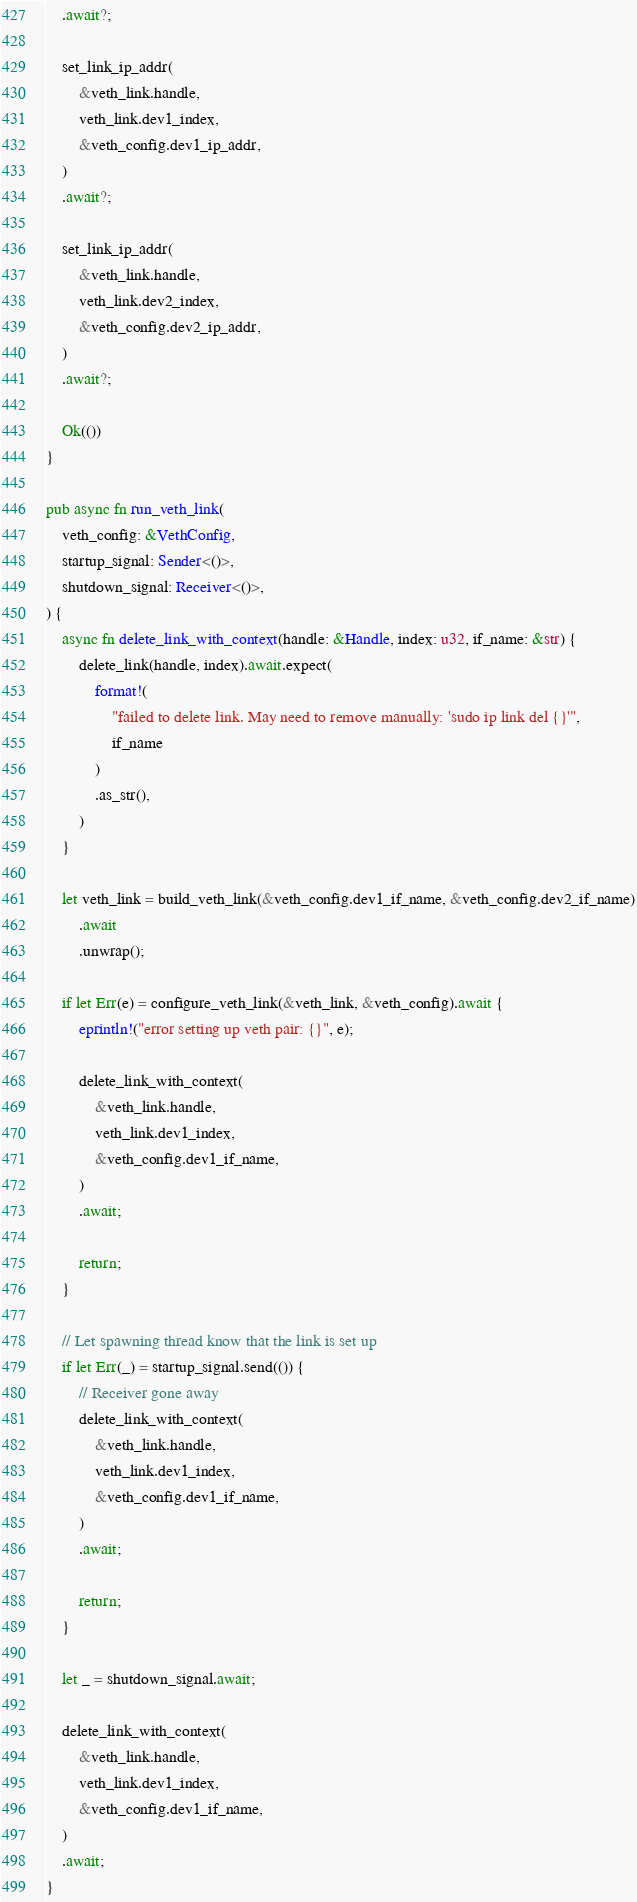Convert code to text. <code><loc_0><loc_0><loc_500><loc_500><_Rust_>    .await?;

    set_link_ip_addr(
        &veth_link.handle,
        veth_link.dev1_index,
        &veth_config.dev1_ip_addr,
    )
    .await?;

    set_link_ip_addr(
        &veth_link.handle,
        veth_link.dev2_index,
        &veth_config.dev2_ip_addr,
    )
    .await?;

    Ok(())
}

pub async fn run_veth_link(
    veth_config: &VethConfig,
    startup_signal: Sender<()>,
    shutdown_signal: Receiver<()>,
) {
    async fn delete_link_with_context(handle: &Handle, index: u32, if_name: &str) {
        delete_link(handle, index).await.expect(
            format!(
                "failed to delete link. May need to remove manually: 'sudo ip link del {}'",
                if_name
            )
            .as_str(),
        )
    }

    let veth_link = build_veth_link(&veth_config.dev1_if_name, &veth_config.dev2_if_name)
        .await
        .unwrap();

    if let Err(e) = configure_veth_link(&veth_link, &veth_config).await {
        eprintln!("error setting up veth pair: {}", e);

        delete_link_with_context(
            &veth_link.handle,
            veth_link.dev1_index,
            &veth_config.dev1_if_name,
        )
        .await;

        return;
    }

    // Let spawning thread know that the link is set up
    if let Err(_) = startup_signal.send(()) {
        // Receiver gone away
        delete_link_with_context(
            &veth_link.handle,
            veth_link.dev1_index,
            &veth_config.dev1_if_name,
        )
        .await;

        return;
    }

    let _ = shutdown_signal.await;

    delete_link_with_context(
        &veth_link.handle,
        veth_link.dev1_index,
        &veth_config.dev1_if_name,
    )
    .await;
}
</code> 